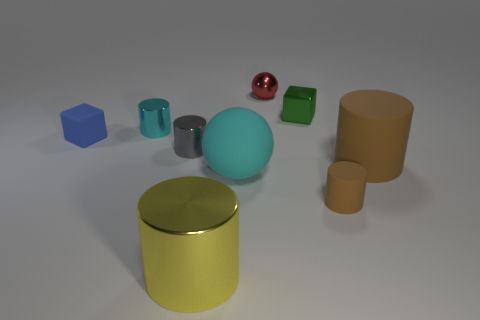Is there anything else that is the same color as the small metallic sphere?
Ensure brevity in your answer.  No. Are there any other objects that have the same shape as the small gray object?
Offer a very short reply. Yes. How many objects are either big cyan rubber spheres or tiny matte objects that are to the right of the green metal cube?
Provide a succinct answer. 2. The tiny matte thing that is on the right side of the small matte block is what color?
Your answer should be compact. Brown. Do the rubber thing left of the small cyan metallic thing and the sphere that is in front of the red object have the same size?
Give a very brief answer. No. Are there any blue things of the same size as the gray thing?
Your answer should be compact. Yes. There is a gray metallic cylinder to the left of the tiny ball; how many tiny cyan cylinders are in front of it?
Ensure brevity in your answer.  0. What material is the big cyan sphere?
Your answer should be compact. Rubber. How many big cylinders are to the right of the blue thing?
Make the answer very short. 2. Does the large metal object have the same color as the tiny metallic sphere?
Provide a short and direct response. No. 